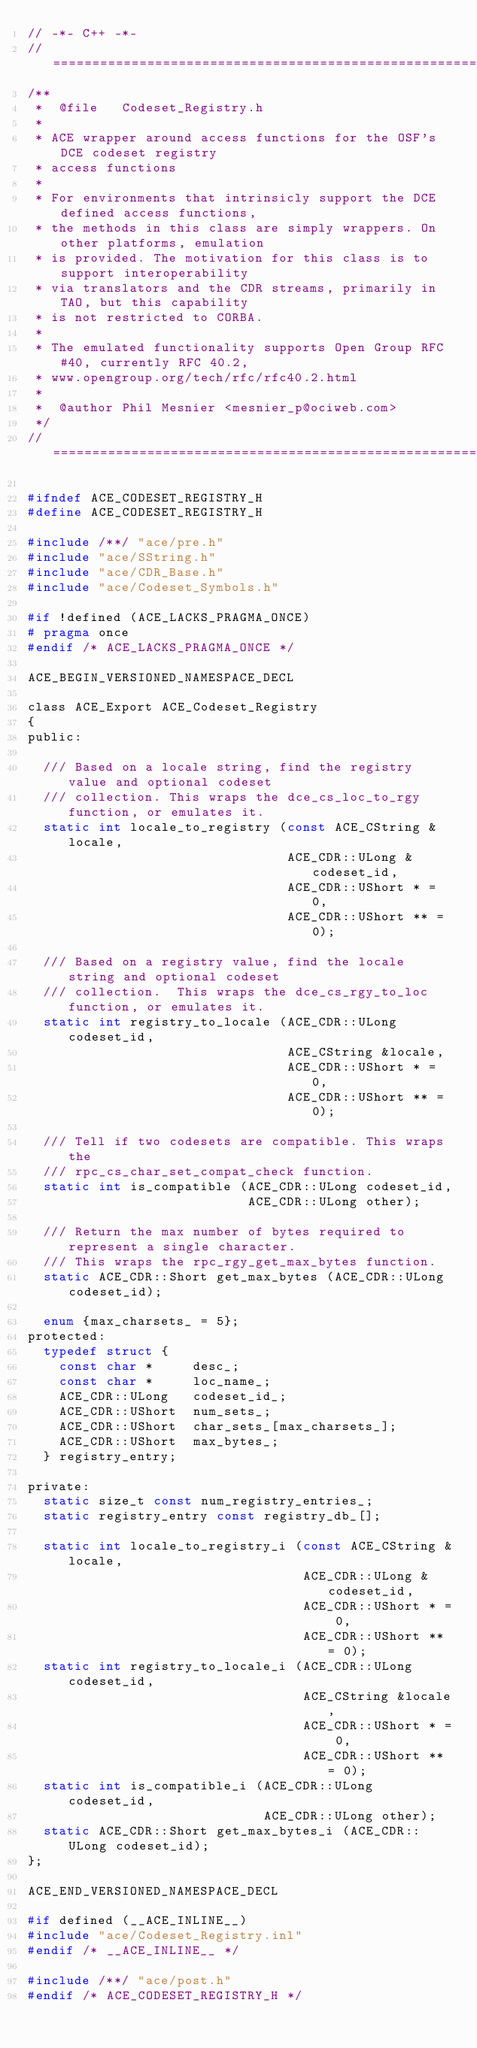<code> <loc_0><loc_0><loc_500><loc_500><_C_>// -*- C++ -*-
//=============================================================================
/**
 *  @file   Codeset_Registry.h
 *
 * ACE wrapper around access functions for the OSF's DCE codeset registry
 * access functions
 *
 * For environments that intrinsicly support the DCE defined access functions,
 * the methods in this class are simply wrappers. On other platforms, emulation
 * is provided. The motivation for this class is to support interoperability
 * via translators and the CDR streams, primarily in TAO, but this capability
 * is not restricted to CORBA.
 *
 * The emulated functionality supports Open Group RFC #40, currently RFC 40.2,
 * www.opengroup.org/tech/rfc/rfc40.2.html
 *
 *  @author Phil Mesnier <mesnier_p@ociweb.com>
 */
//=============================================================================

#ifndef ACE_CODESET_REGISTRY_H
#define ACE_CODESET_REGISTRY_H

#include /**/ "ace/pre.h"
#include "ace/SString.h"
#include "ace/CDR_Base.h"
#include "ace/Codeset_Symbols.h"

#if !defined (ACE_LACKS_PRAGMA_ONCE)
# pragma once
#endif /* ACE_LACKS_PRAGMA_ONCE */

ACE_BEGIN_VERSIONED_NAMESPACE_DECL

class ACE_Export ACE_Codeset_Registry
{
public:

  /// Based on a locale string, find the registry value and optional codeset
  /// collection. This wraps the dce_cs_loc_to_rgy function, or emulates it.
  static int locale_to_registry (const ACE_CString &locale,
                                 ACE_CDR::ULong &codeset_id,
                                 ACE_CDR::UShort * = 0,
                                 ACE_CDR::UShort ** = 0);

  /// Based on a registry value, find the locale string and optional codeset
  /// collection.  This wraps the dce_cs_rgy_to_loc function, or emulates it.
  static int registry_to_locale (ACE_CDR::ULong codeset_id,
                                 ACE_CString &locale,
                                 ACE_CDR::UShort * = 0,
                                 ACE_CDR::UShort ** = 0);

  /// Tell if two codesets are compatible. This wraps the
  /// rpc_cs_char_set_compat_check function.
  static int is_compatible (ACE_CDR::ULong codeset_id,
                            ACE_CDR::ULong other);

  /// Return the max number of bytes required to represent a single character.
  /// This wraps the rpc_rgy_get_max_bytes function.
  static ACE_CDR::Short get_max_bytes (ACE_CDR::ULong codeset_id);

  enum {max_charsets_ = 5};
protected:
  typedef struct {
    const char *     desc_;
    const char *     loc_name_;
    ACE_CDR::ULong   codeset_id_;
    ACE_CDR::UShort  num_sets_;
    ACE_CDR::UShort  char_sets_[max_charsets_];
    ACE_CDR::UShort  max_bytes_;
  } registry_entry;

private:
  static size_t const num_registry_entries_;
  static registry_entry const registry_db_[];

  static int locale_to_registry_i (const ACE_CString &locale,
                                   ACE_CDR::ULong &codeset_id,
                                   ACE_CDR::UShort * = 0,
                                   ACE_CDR::UShort ** = 0);
  static int registry_to_locale_i (ACE_CDR::ULong codeset_id,
                                   ACE_CString &locale,
                                   ACE_CDR::UShort * = 0,
                                   ACE_CDR::UShort ** = 0);
  static int is_compatible_i (ACE_CDR::ULong codeset_id,
                              ACE_CDR::ULong other);
  static ACE_CDR::Short get_max_bytes_i (ACE_CDR::ULong codeset_id);
};

ACE_END_VERSIONED_NAMESPACE_DECL

#if defined (__ACE_INLINE__)
#include "ace/Codeset_Registry.inl"
#endif /* __ACE_INLINE__ */

#include /**/ "ace/post.h"
#endif /* ACE_CODESET_REGISTRY_H */
</code> 